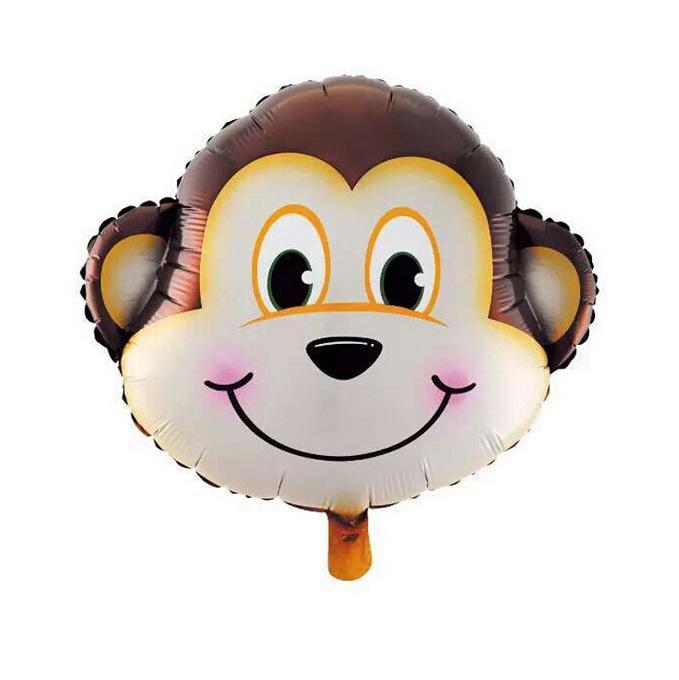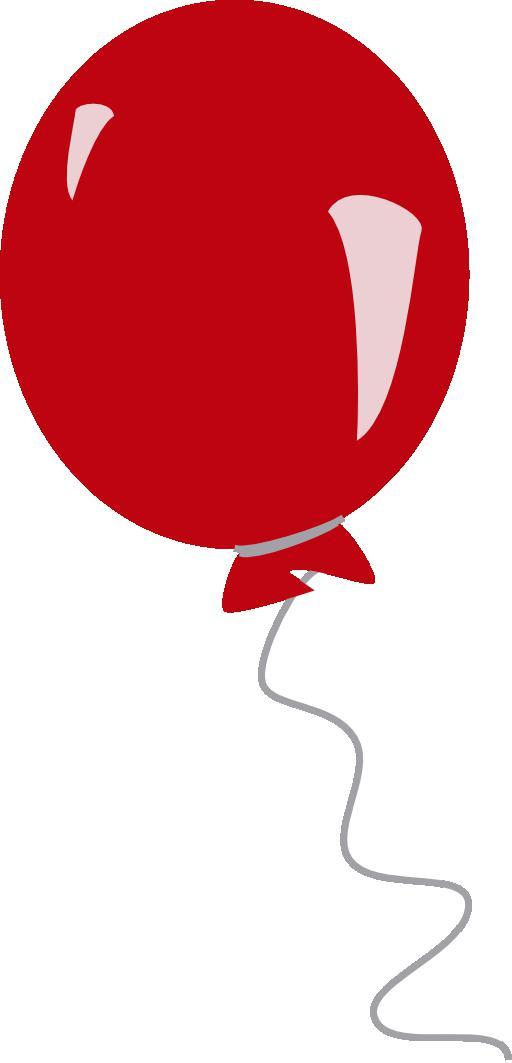The first image is the image on the left, the second image is the image on the right. For the images displayed, is the sentence "One of the balloons is a dog that is wearing a collar and standing on four folded paper legs." factually correct? Answer yes or no. No. 